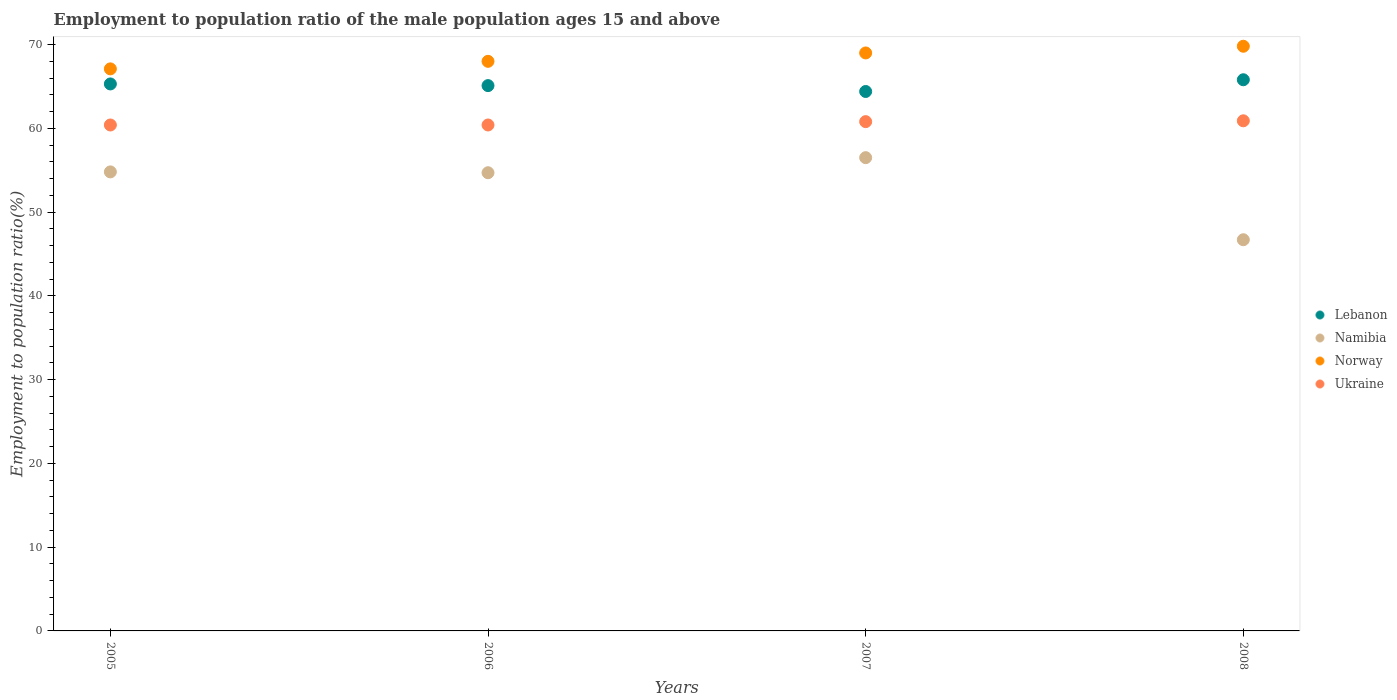What is the employment to population ratio in Lebanon in 2007?
Offer a very short reply. 64.4. Across all years, what is the maximum employment to population ratio in Namibia?
Make the answer very short. 56.5. Across all years, what is the minimum employment to population ratio in Ukraine?
Offer a very short reply. 60.4. What is the total employment to population ratio in Lebanon in the graph?
Your response must be concise. 260.6. What is the difference between the employment to population ratio in Lebanon in 2005 and that in 2007?
Ensure brevity in your answer.  0.9. What is the difference between the employment to population ratio in Norway in 2006 and the employment to population ratio in Lebanon in 2007?
Your answer should be very brief. 3.6. What is the average employment to population ratio in Lebanon per year?
Give a very brief answer. 65.15. In the year 2005, what is the difference between the employment to population ratio in Lebanon and employment to population ratio in Norway?
Provide a short and direct response. -1.8. In how many years, is the employment to population ratio in Lebanon greater than 52 %?
Make the answer very short. 4. What is the ratio of the employment to population ratio in Lebanon in 2005 to that in 2007?
Make the answer very short. 1.01. Is the employment to population ratio in Norway in 2005 less than that in 2006?
Offer a very short reply. Yes. What is the difference between the highest and the second highest employment to population ratio in Namibia?
Give a very brief answer. 1.7. What is the difference between the highest and the lowest employment to population ratio in Ukraine?
Ensure brevity in your answer.  0.5. Is the sum of the employment to population ratio in Lebanon in 2005 and 2008 greater than the maximum employment to population ratio in Ukraine across all years?
Your response must be concise. Yes. Is it the case that in every year, the sum of the employment to population ratio in Ukraine and employment to population ratio in Norway  is greater than the employment to population ratio in Namibia?
Ensure brevity in your answer.  Yes. Does the employment to population ratio in Ukraine monotonically increase over the years?
Ensure brevity in your answer.  No. Is the employment to population ratio in Ukraine strictly greater than the employment to population ratio in Lebanon over the years?
Offer a very short reply. No. How many dotlines are there?
Ensure brevity in your answer.  4. How many years are there in the graph?
Offer a very short reply. 4. What is the difference between two consecutive major ticks on the Y-axis?
Make the answer very short. 10. Does the graph contain any zero values?
Provide a short and direct response. No. Does the graph contain grids?
Ensure brevity in your answer.  No. How are the legend labels stacked?
Provide a succinct answer. Vertical. What is the title of the graph?
Provide a succinct answer. Employment to population ratio of the male population ages 15 and above. Does "Tunisia" appear as one of the legend labels in the graph?
Ensure brevity in your answer.  No. What is the Employment to population ratio(%) of Lebanon in 2005?
Provide a short and direct response. 65.3. What is the Employment to population ratio(%) of Namibia in 2005?
Keep it short and to the point. 54.8. What is the Employment to population ratio(%) in Norway in 2005?
Keep it short and to the point. 67.1. What is the Employment to population ratio(%) of Ukraine in 2005?
Your response must be concise. 60.4. What is the Employment to population ratio(%) of Lebanon in 2006?
Your answer should be compact. 65.1. What is the Employment to population ratio(%) of Namibia in 2006?
Ensure brevity in your answer.  54.7. What is the Employment to population ratio(%) of Ukraine in 2006?
Your answer should be compact. 60.4. What is the Employment to population ratio(%) of Lebanon in 2007?
Give a very brief answer. 64.4. What is the Employment to population ratio(%) in Namibia in 2007?
Offer a very short reply. 56.5. What is the Employment to population ratio(%) in Norway in 2007?
Provide a succinct answer. 69. What is the Employment to population ratio(%) in Ukraine in 2007?
Make the answer very short. 60.8. What is the Employment to population ratio(%) in Lebanon in 2008?
Provide a succinct answer. 65.8. What is the Employment to population ratio(%) of Namibia in 2008?
Offer a very short reply. 46.7. What is the Employment to population ratio(%) in Norway in 2008?
Your answer should be very brief. 69.8. What is the Employment to population ratio(%) of Ukraine in 2008?
Give a very brief answer. 60.9. Across all years, what is the maximum Employment to population ratio(%) in Lebanon?
Your answer should be compact. 65.8. Across all years, what is the maximum Employment to population ratio(%) in Namibia?
Keep it short and to the point. 56.5. Across all years, what is the maximum Employment to population ratio(%) in Norway?
Offer a terse response. 69.8. Across all years, what is the maximum Employment to population ratio(%) in Ukraine?
Ensure brevity in your answer.  60.9. Across all years, what is the minimum Employment to population ratio(%) in Lebanon?
Provide a short and direct response. 64.4. Across all years, what is the minimum Employment to population ratio(%) of Namibia?
Make the answer very short. 46.7. Across all years, what is the minimum Employment to population ratio(%) in Norway?
Provide a short and direct response. 67.1. Across all years, what is the minimum Employment to population ratio(%) of Ukraine?
Your answer should be compact. 60.4. What is the total Employment to population ratio(%) in Lebanon in the graph?
Offer a very short reply. 260.6. What is the total Employment to population ratio(%) in Namibia in the graph?
Your response must be concise. 212.7. What is the total Employment to population ratio(%) of Norway in the graph?
Provide a succinct answer. 273.9. What is the total Employment to population ratio(%) in Ukraine in the graph?
Provide a succinct answer. 242.5. What is the difference between the Employment to population ratio(%) in Norway in 2005 and that in 2006?
Make the answer very short. -0.9. What is the difference between the Employment to population ratio(%) of Ukraine in 2005 and that in 2006?
Offer a very short reply. 0. What is the difference between the Employment to population ratio(%) in Namibia in 2005 and that in 2007?
Your answer should be very brief. -1.7. What is the difference between the Employment to population ratio(%) of Norway in 2005 and that in 2007?
Your answer should be very brief. -1.9. What is the difference between the Employment to population ratio(%) in Namibia in 2006 and that in 2007?
Offer a terse response. -1.8. What is the difference between the Employment to population ratio(%) in Ukraine in 2006 and that in 2007?
Ensure brevity in your answer.  -0.4. What is the difference between the Employment to population ratio(%) in Namibia in 2006 and that in 2008?
Ensure brevity in your answer.  8. What is the difference between the Employment to population ratio(%) in Norway in 2006 and that in 2008?
Make the answer very short. -1.8. What is the difference between the Employment to population ratio(%) of Ukraine in 2006 and that in 2008?
Give a very brief answer. -0.5. What is the difference between the Employment to population ratio(%) of Lebanon in 2007 and that in 2008?
Your answer should be compact. -1.4. What is the difference between the Employment to population ratio(%) of Norway in 2007 and that in 2008?
Ensure brevity in your answer.  -0.8. What is the difference between the Employment to population ratio(%) in Ukraine in 2007 and that in 2008?
Your answer should be compact. -0.1. What is the difference between the Employment to population ratio(%) of Lebanon in 2005 and the Employment to population ratio(%) of Norway in 2006?
Make the answer very short. -2.7. What is the difference between the Employment to population ratio(%) of Lebanon in 2005 and the Employment to population ratio(%) of Ukraine in 2006?
Provide a short and direct response. 4.9. What is the difference between the Employment to population ratio(%) in Lebanon in 2005 and the Employment to population ratio(%) in Namibia in 2007?
Make the answer very short. 8.8. What is the difference between the Employment to population ratio(%) in Lebanon in 2005 and the Employment to population ratio(%) in Norway in 2007?
Provide a succinct answer. -3.7. What is the difference between the Employment to population ratio(%) in Lebanon in 2005 and the Employment to population ratio(%) in Ukraine in 2007?
Provide a succinct answer. 4.5. What is the difference between the Employment to population ratio(%) in Namibia in 2005 and the Employment to population ratio(%) in Ukraine in 2007?
Provide a succinct answer. -6. What is the difference between the Employment to population ratio(%) in Norway in 2005 and the Employment to population ratio(%) in Ukraine in 2007?
Ensure brevity in your answer.  6.3. What is the difference between the Employment to population ratio(%) of Lebanon in 2005 and the Employment to population ratio(%) of Namibia in 2008?
Provide a succinct answer. 18.6. What is the difference between the Employment to population ratio(%) in Lebanon in 2005 and the Employment to population ratio(%) in Norway in 2008?
Your answer should be compact. -4.5. What is the difference between the Employment to population ratio(%) in Namibia in 2005 and the Employment to population ratio(%) in Norway in 2008?
Your answer should be very brief. -15. What is the difference between the Employment to population ratio(%) of Namibia in 2005 and the Employment to population ratio(%) of Ukraine in 2008?
Offer a very short reply. -6.1. What is the difference between the Employment to population ratio(%) of Norway in 2005 and the Employment to population ratio(%) of Ukraine in 2008?
Provide a succinct answer. 6.2. What is the difference between the Employment to population ratio(%) in Lebanon in 2006 and the Employment to population ratio(%) in Namibia in 2007?
Make the answer very short. 8.6. What is the difference between the Employment to population ratio(%) of Lebanon in 2006 and the Employment to population ratio(%) of Norway in 2007?
Keep it short and to the point. -3.9. What is the difference between the Employment to population ratio(%) in Namibia in 2006 and the Employment to population ratio(%) in Norway in 2007?
Ensure brevity in your answer.  -14.3. What is the difference between the Employment to population ratio(%) of Norway in 2006 and the Employment to population ratio(%) of Ukraine in 2007?
Keep it short and to the point. 7.2. What is the difference between the Employment to population ratio(%) of Namibia in 2006 and the Employment to population ratio(%) of Norway in 2008?
Make the answer very short. -15.1. What is the difference between the Employment to population ratio(%) in Lebanon in 2007 and the Employment to population ratio(%) in Namibia in 2008?
Provide a succinct answer. 17.7. What is the difference between the Employment to population ratio(%) of Lebanon in 2007 and the Employment to population ratio(%) of Ukraine in 2008?
Ensure brevity in your answer.  3.5. What is the difference between the Employment to population ratio(%) in Namibia in 2007 and the Employment to population ratio(%) in Ukraine in 2008?
Offer a very short reply. -4.4. What is the difference between the Employment to population ratio(%) in Norway in 2007 and the Employment to population ratio(%) in Ukraine in 2008?
Offer a very short reply. 8.1. What is the average Employment to population ratio(%) of Lebanon per year?
Give a very brief answer. 65.15. What is the average Employment to population ratio(%) in Namibia per year?
Offer a very short reply. 53.17. What is the average Employment to population ratio(%) of Norway per year?
Provide a short and direct response. 68.47. What is the average Employment to population ratio(%) of Ukraine per year?
Ensure brevity in your answer.  60.62. In the year 2005, what is the difference between the Employment to population ratio(%) in Lebanon and Employment to population ratio(%) in Ukraine?
Your answer should be compact. 4.9. In the year 2006, what is the difference between the Employment to population ratio(%) in Lebanon and Employment to population ratio(%) in Namibia?
Offer a very short reply. 10.4. In the year 2006, what is the difference between the Employment to population ratio(%) of Namibia and Employment to population ratio(%) of Norway?
Offer a very short reply. -13.3. In the year 2007, what is the difference between the Employment to population ratio(%) of Lebanon and Employment to population ratio(%) of Namibia?
Make the answer very short. 7.9. In the year 2007, what is the difference between the Employment to population ratio(%) of Lebanon and Employment to population ratio(%) of Ukraine?
Offer a very short reply. 3.6. In the year 2007, what is the difference between the Employment to population ratio(%) of Namibia and Employment to population ratio(%) of Ukraine?
Give a very brief answer. -4.3. In the year 2007, what is the difference between the Employment to population ratio(%) in Norway and Employment to population ratio(%) in Ukraine?
Make the answer very short. 8.2. In the year 2008, what is the difference between the Employment to population ratio(%) in Lebanon and Employment to population ratio(%) in Namibia?
Offer a very short reply. 19.1. In the year 2008, what is the difference between the Employment to population ratio(%) of Lebanon and Employment to population ratio(%) of Norway?
Offer a very short reply. -4. In the year 2008, what is the difference between the Employment to population ratio(%) of Lebanon and Employment to population ratio(%) of Ukraine?
Your response must be concise. 4.9. In the year 2008, what is the difference between the Employment to population ratio(%) of Namibia and Employment to population ratio(%) of Norway?
Provide a succinct answer. -23.1. In the year 2008, what is the difference between the Employment to population ratio(%) in Namibia and Employment to population ratio(%) in Ukraine?
Offer a terse response. -14.2. What is the ratio of the Employment to population ratio(%) in Norway in 2005 to that in 2006?
Provide a succinct answer. 0.99. What is the ratio of the Employment to population ratio(%) in Lebanon in 2005 to that in 2007?
Keep it short and to the point. 1.01. What is the ratio of the Employment to population ratio(%) in Namibia in 2005 to that in 2007?
Ensure brevity in your answer.  0.97. What is the ratio of the Employment to population ratio(%) in Norway in 2005 to that in 2007?
Offer a terse response. 0.97. What is the ratio of the Employment to population ratio(%) in Ukraine in 2005 to that in 2007?
Your answer should be very brief. 0.99. What is the ratio of the Employment to population ratio(%) in Namibia in 2005 to that in 2008?
Make the answer very short. 1.17. What is the ratio of the Employment to population ratio(%) in Norway in 2005 to that in 2008?
Offer a very short reply. 0.96. What is the ratio of the Employment to population ratio(%) of Ukraine in 2005 to that in 2008?
Make the answer very short. 0.99. What is the ratio of the Employment to population ratio(%) of Lebanon in 2006 to that in 2007?
Your answer should be very brief. 1.01. What is the ratio of the Employment to population ratio(%) in Namibia in 2006 to that in 2007?
Your response must be concise. 0.97. What is the ratio of the Employment to population ratio(%) of Norway in 2006 to that in 2007?
Your response must be concise. 0.99. What is the ratio of the Employment to population ratio(%) of Ukraine in 2006 to that in 2007?
Your answer should be very brief. 0.99. What is the ratio of the Employment to population ratio(%) in Namibia in 2006 to that in 2008?
Your answer should be compact. 1.17. What is the ratio of the Employment to population ratio(%) of Norway in 2006 to that in 2008?
Your answer should be very brief. 0.97. What is the ratio of the Employment to population ratio(%) of Ukraine in 2006 to that in 2008?
Ensure brevity in your answer.  0.99. What is the ratio of the Employment to population ratio(%) in Lebanon in 2007 to that in 2008?
Your answer should be very brief. 0.98. What is the ratio of the Employment to population ratio(%) in Namibia in 2007 to that in 2008?
Keep it short and to the point. 1.21. What is the ratio of the Employment to population ratio(%) of Norway in 2007 to that in 2008?
Make the answer very short. 0.99. What is the difference between the highest and the second highest Employment to population ratio(%) in Ukraine?
Provide a short and direct response. 0.1. What is the difference between the highest and the lowest Employment to population ratio(%) of Ukraine?
Make the answer very short. 0.5. 